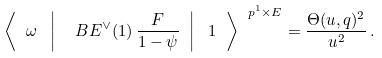Convert formula to latex. <formula><loc_0><loc_0><loc_500><loc_500>\left \langle \ \omega \ \left | \ \ B E ^ { \vee } ( 1 ) \, \frac { F } { 1 - \psi } \ \right | \ 1 \ \right \rangle ^ { \ p ^ { 1 } \times E } = \frac { \Theta ( u , q ) ^ { 2 } } { u ^ { 2 } } \, .</formula> 